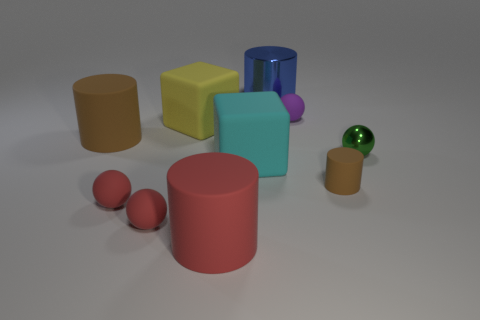Subtract 1 cylinders. How many cylinders are left? 3 Subtract all purple spheres. How many spheres are left? 3 Subtract all red rubber cylinders. How many cylinders are left? 3 Subtract all yellow balls. Subtract all blue cylinders. How many balls are left? 4 Subtract all spheres. How many objects are left? 6 Subtract all purple objects. Subtract all big cyan cubes. How many objects are left? 8 Add 6 big blue cylinders. How many big blue cylinders are left? 7 Add 4 rubber balls. How many rubber balls exist? 7 Subtract 0 brown spheres. How many objects are left? 10 